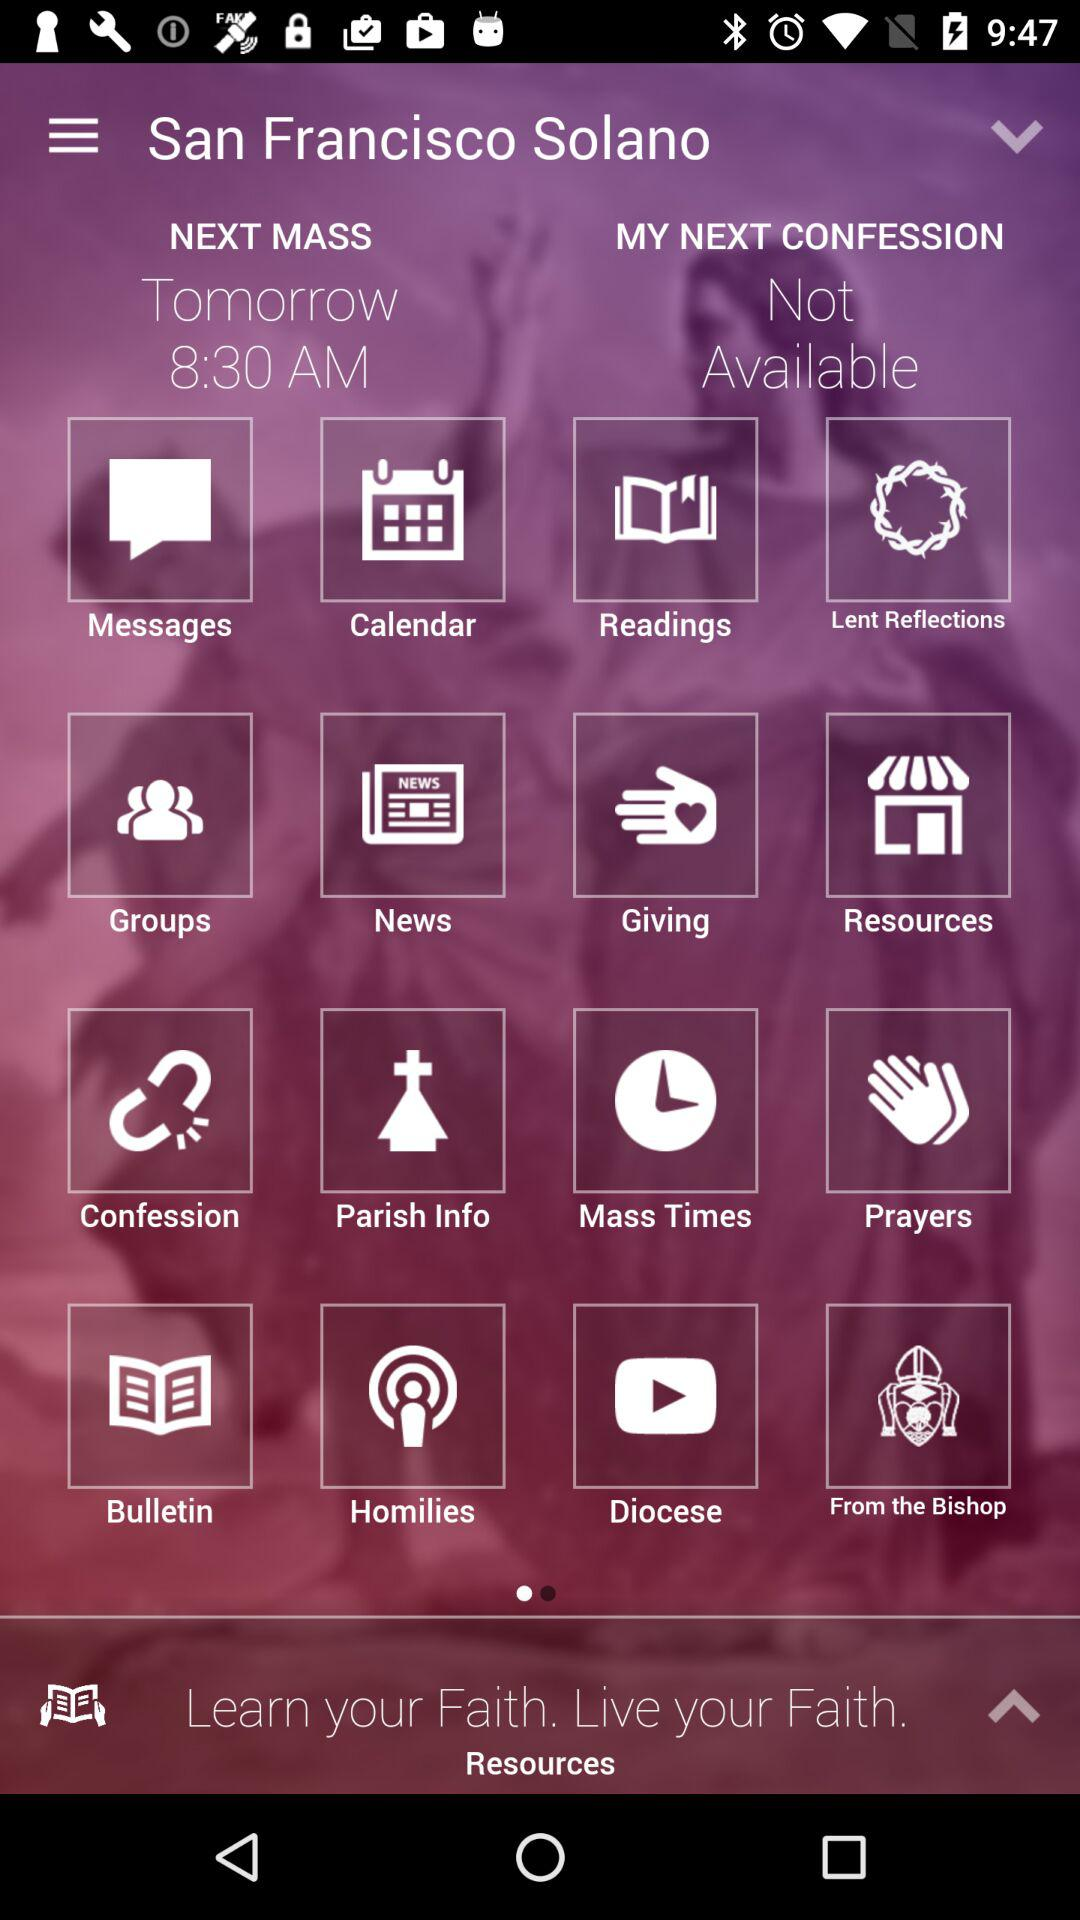At what time does the "NEXT MASS" become available? The "NEXT MASS" will become available tomorrow at 8:30 AM. 